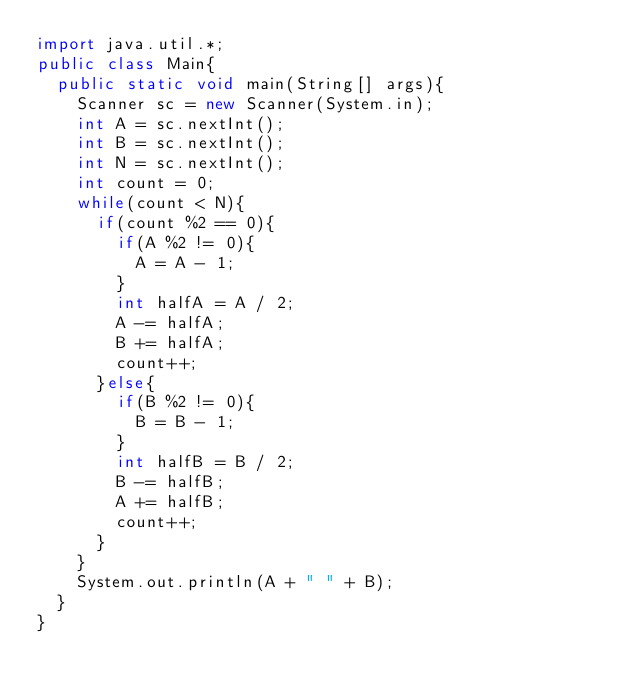Convert code to text. <code><loc_0><loc_0><loc_500><loc_500><_Java_>import java.util.*;
public class Main{
  public static void main(String[] args){
    Scanner sc = new Scanner(System.in);
    int A = sc.nextInt();
    int B = sc.nextInt();
    int N = sc.nextInt();
    int count = 0;
    while(count < N){
      if(count %2 == 0){
        if(A %2 != 0){
          A = A - 1;
        }
        int halfA = A / 2;
        A -= halfA;
        B += halfA;
        count++;
      }else{
        if(B %2 != 0){
          B = B - 1;
        }
        int halfB = B / 2;
        B -= halfB;
        A += halfB;
        count++;
      }
    }
    System.out.println(A + " " + B);
  }
}
</code> 